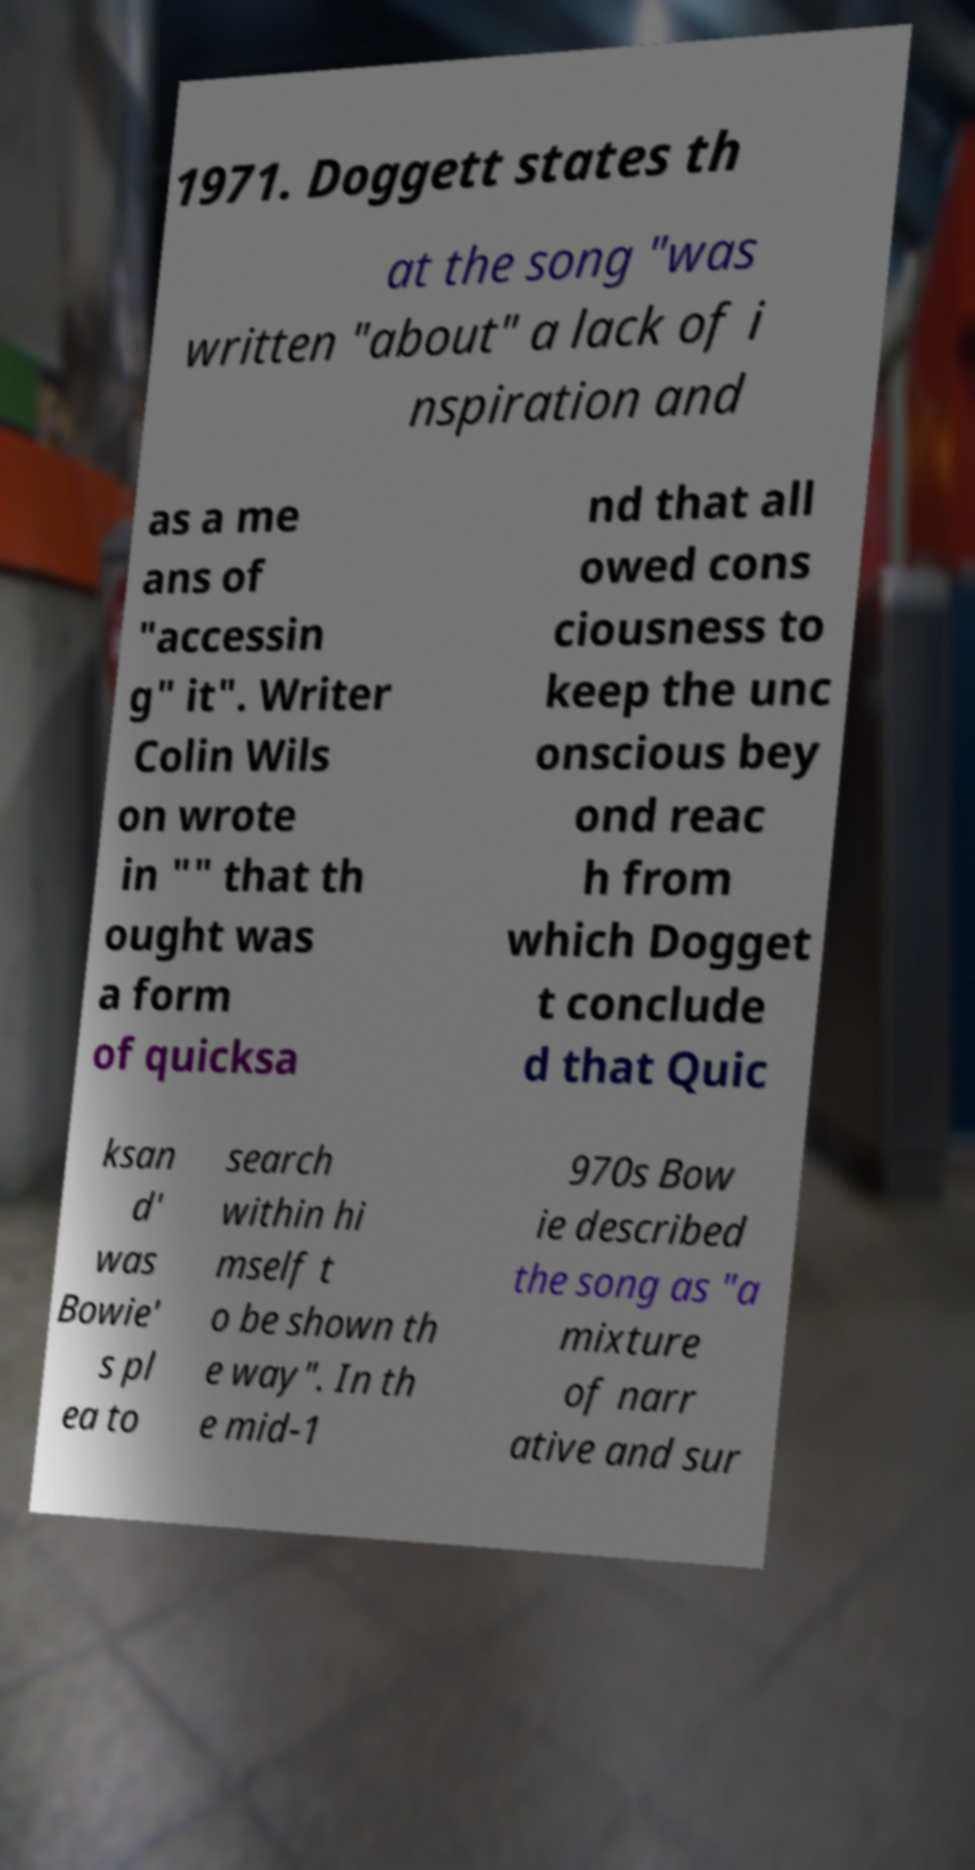Can you accurately transcribe the text from the provided image for me? 1971. Doggett states th at the song "was written "about" a lack of i nspiration and as a me ans of "accessin g" it". Writer Colin Wils on wrote in "" that th ought was a form of quicksa nd that all owed cons ciousness to keep the unc onscious bey ond reac h from which Dogget t conclude d that Quic ksan d' was Bowie' s pl ea to search within hi mself t o be shown th e way". In th e mid-1 970s Bow ie described the song as "a mixture of narr ative and sur 